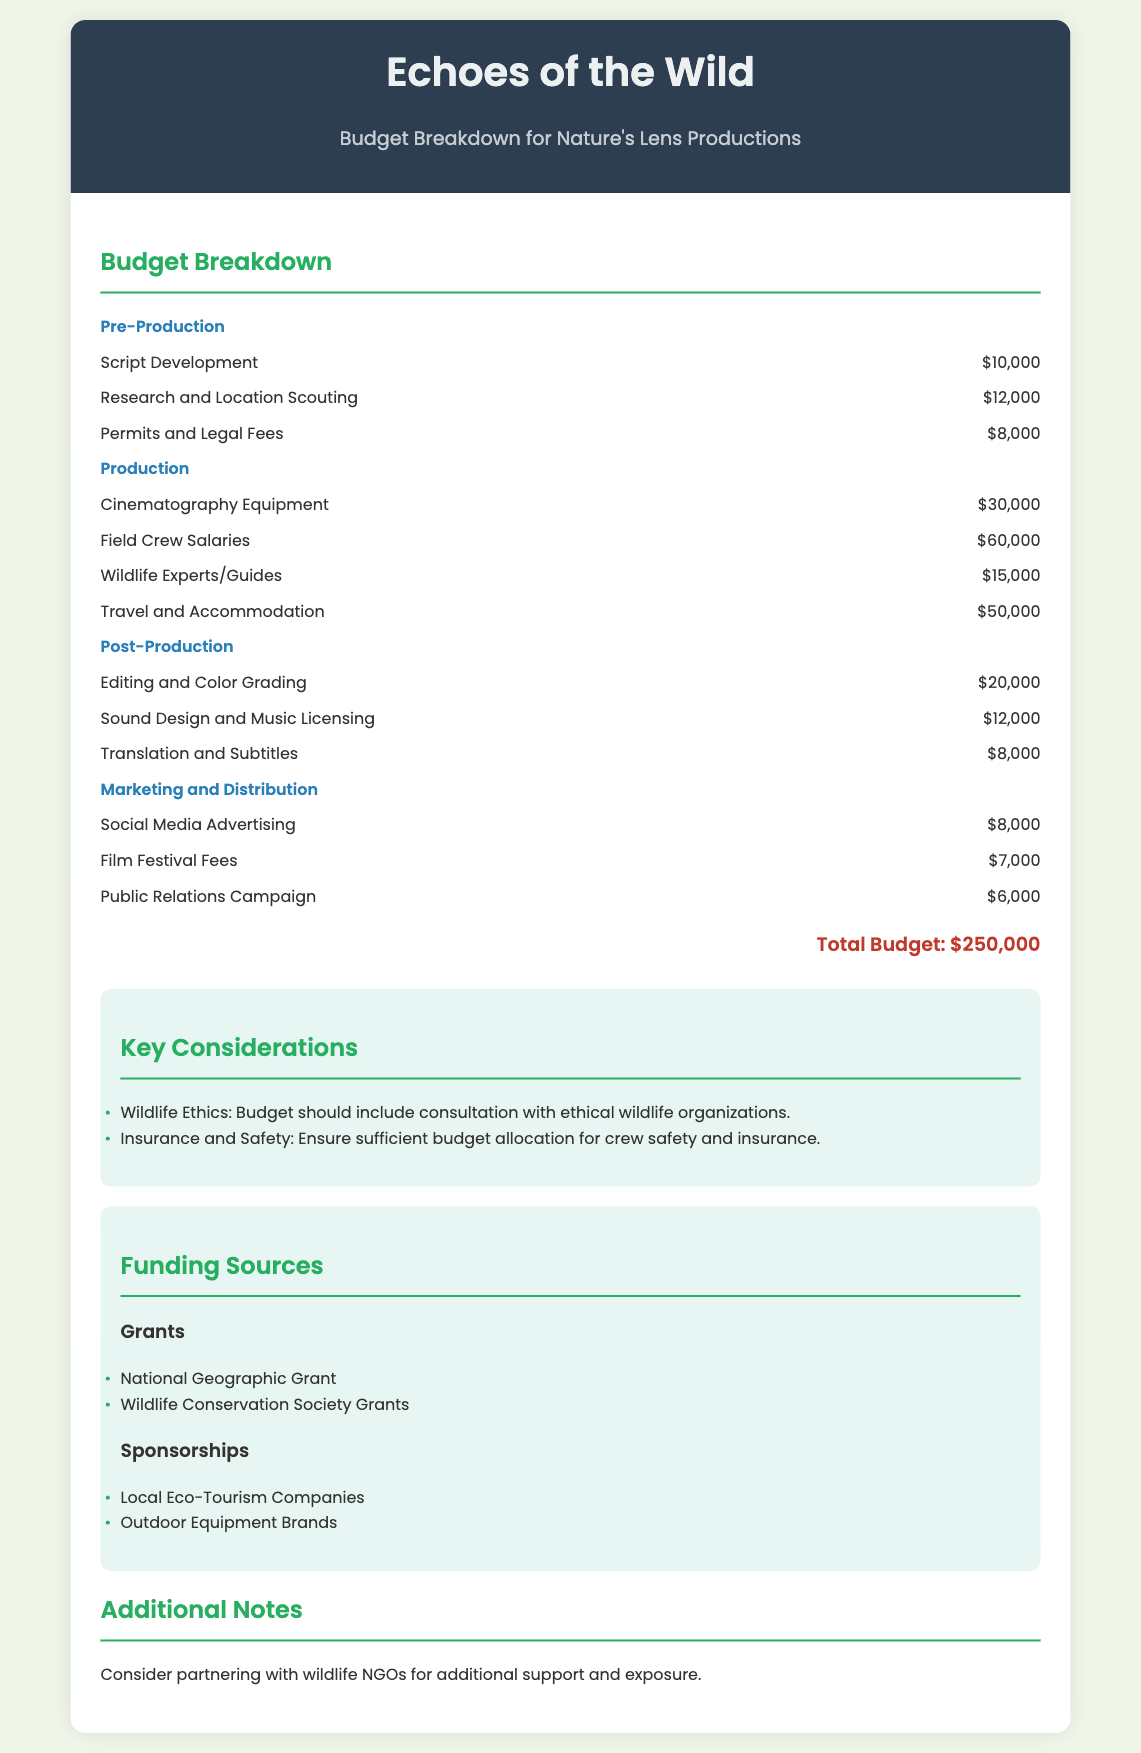what is the total budget? The total budget is listed at the end of the document, summing all expenses to $250,000.
Answer: $250,000 how much is allocated for travel and accommodation? The travel and accommodation expenses can be found under Production, where it states the amount as $50,000.
Answer: $50,000 what is the budget for script development? The budget for script development is listed under Pre-Production, which specifies the amount as $10,000.
Answer: $10,000 how many grants are mentioned as funding sources? The document lists two types of grants as funding sources: National Geographic Grant and Wildlife Conservation Society Grants.
Answer: 2 what is one key consideration for the budget? The document mentions wildlife ethics and insurance and safety as key considerations, which highlights the importance of ethical practices and safety measures.
Answer: Wildlife Ethics how much is budgeted for editing and color grading? The editing and color grading expenses can be found under Post-Production, where it is outlined as $20,000.
Answer: $20,000 what is the budget allocation for social media advertising? The budget for social media advertising is identified in the Marketing and Distribution section as $8,000.
Answer: $8,000 what is one type of sponsorship mentioned? The document mentions local eco-tourism companies as a type of sponsorship available.
Answer: Local Eco-Tourism Companies how much is budgeted for wildlife experts/guides? The budget for wildlife experts/guides is listed under Production as $15,000.
Answer: $15,000 